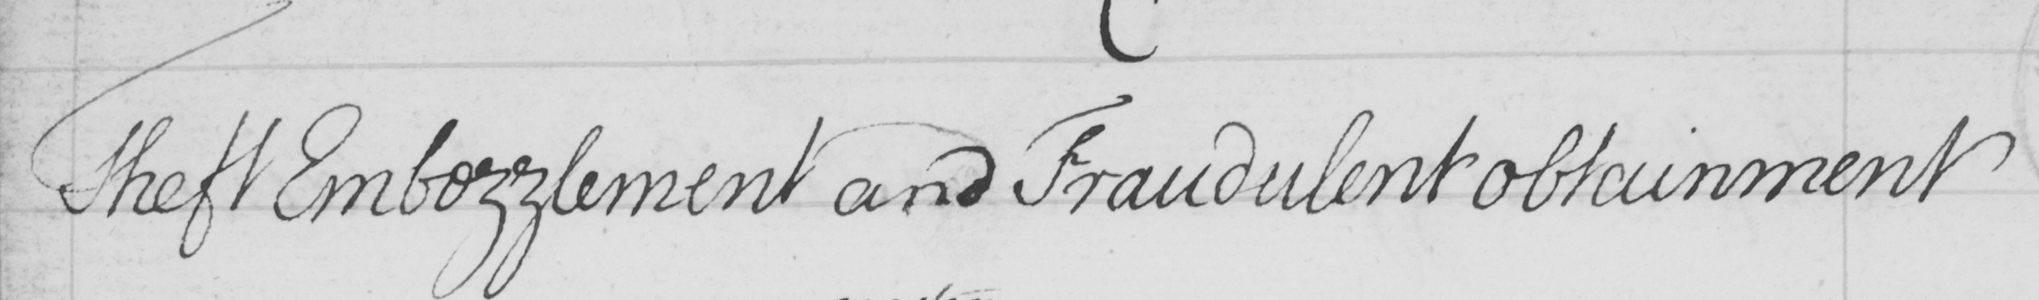Can you tell me what this handwritten text says? Theft Embezzlement and Fraudulent obtainment 